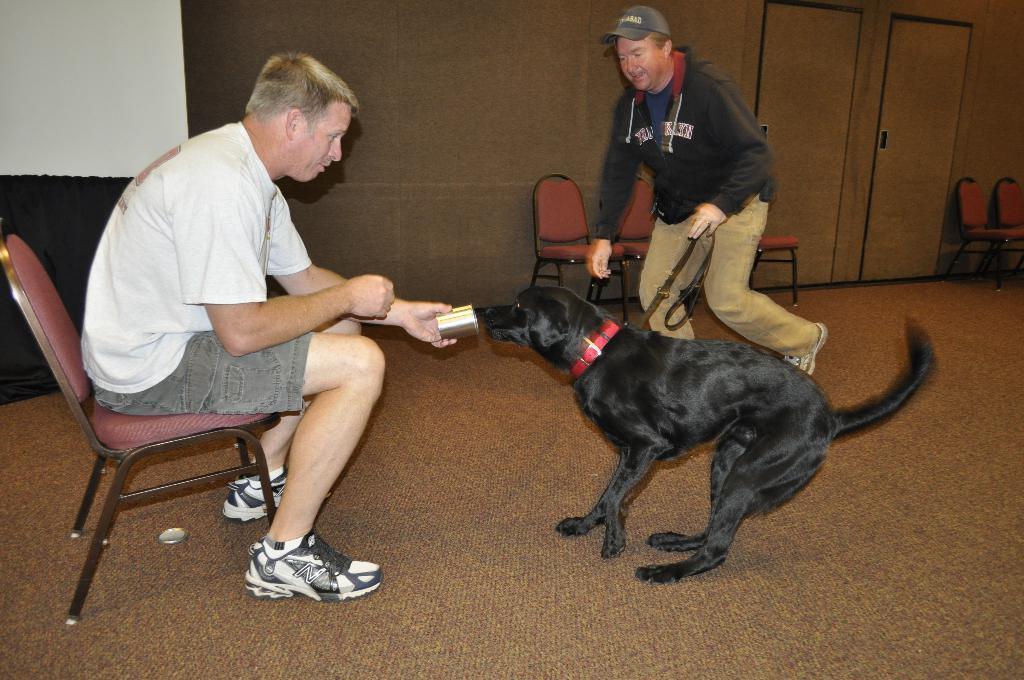Please provide a concise description of this image. In this picture we can see two persons were one man sitting on chair and giving some utensil to dog and other man is running holding rope in his hand and in background we can see wall, doors, chairs. 